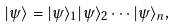Convert formula to latex. <formula><loc_0><loc_0><loc_500><loc_500>| \psi \rangle = | \psi \rangle _ { 1 } | \psi \rangle _ { 2 } \cdots | \psi \rangle _ { n } ,</formula> 